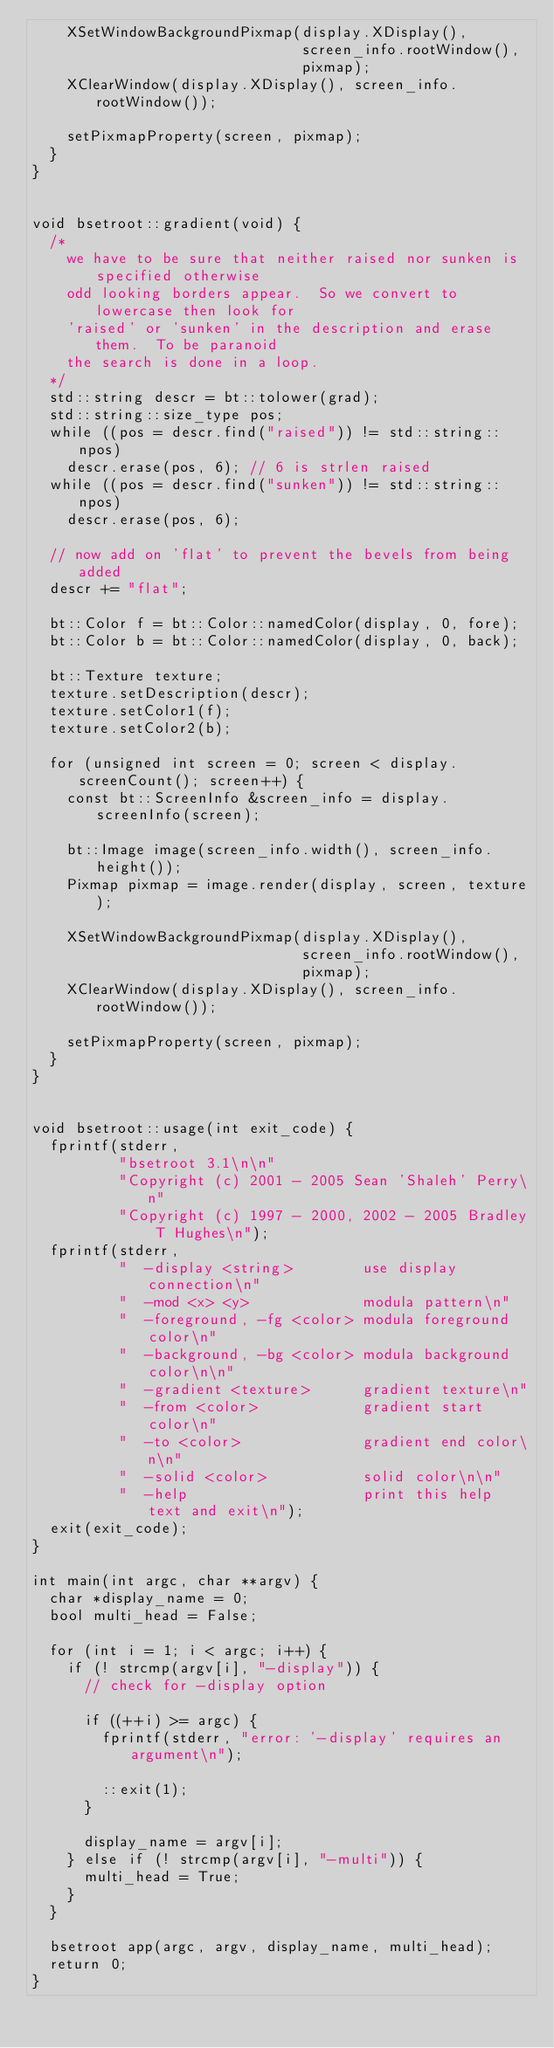Convert code to text. <code><loc_0><loc_0><loc_500><loc_500><_C++_>    XSetWindowBackgroundPixmap(display.XDisplay(),
                               screen_info.rootWindow(),
                               pixmap);
    XClearWindow(display.XDisplay(), screen_info.rootWindow());

    setPixmapProperty(screen, pixmap);
  }
}


void bsetroot::gradient(void) {
  /*
    we have to be sure that neither raised nor sunken is specified otherwise
    odd looking borders appear.  So we convert to lowercase then look for
    'raised' or 'sunken' in the description and erase them.  To be paranoid
    the search is done in a loop.
  */
  std::string descr = bt::tolower(grad);
  std::string::size_type pos;
  while ((pos = descr.find("raised")) != std::string::npos)
    descr.erase(pos, 6); // 6 is strlen raised
  while ((pos = descr.find("sunken")) != std::string::npos)
    descr.erase(pos, 6);

  // now add on 'flat' to prevent the bevels from being added
  descr += "flat";

  bt::Color f = bt::Color::namedColor(display, 0, fore);
  bt::Color b = bt::Color::namedColor(display, 0, back);

  bt::Texture texture;
  texture.setDescription(descr);
  texture.setColor1(f);
  texture.setColor2(b);

  for (unsigned int screen = 0; screen < display.screenCount(); screen++) {
    const bt::ScreenInfo &screen_info = display.screenInfo(screen);

    bt::Image image(screen_info.width(), screen_info.height());
    Pixmap pixmap = image.render(display, screen, texture);

    XSetWindowBackgroundPixmap(display.XDisplay(),
                               screen_info.rootWindow(),
                               pixmap);
    XClearWindow(display.XDisplay(), screen_info.rootWindow());

    setPixmapProperty(screen, pixmap);
  }
}


void bsetroot::usage(int exit_code) {
  fprintf(stderr,
          "bsetroot 3.1\n\n"
          "Copyright (c) 2001 - 2005 Sean 'Shaleh' Perry\n"
          "Copyright (c) 1997 - 2000, 2002 - 2005 Bradley T Hughes\n");
  fprintf(stderr,
          "  -display <string>        use display connection\n"
          "  -mod <x> <y>             modula pattern\n"
          "  -foreground, -fg <color> modula foreground color\n"
          "  -background, -bg <color> modula background color\n\n"
          "  -gradient <texture>      gradient texture\n"
          "  -from <color>            gradient start color\n"
          "  -to <color>              gradient end color\n\n"
          "  -solid <color>           solid color\n\n"
          "  -help                    print this help text and exit\n");
  exit(exit_code);
}

int main(int argc, char **argv) {
  char *display_name = 0;
  bool multi_head = False;

  for (int i = 1; i < argc; i++) {
    if (! strcmp(argv[i], "-display")) {
      // check for -display option

      if ((++i) >= argc) {
        fprintf(stderr, "error: '-display' requires an argument\n");

        ::exit(1);
      }

      display_name = argv[i];
    } else if (! strcmp(argv[i], "-multi")) {
      multi_head = True;
    }
  }

  bsetroot app(argc, argv, display_name, multi_head);
  return 0;
}
</code> 